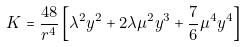Convert formula to latex. <formula><loc_0><loc_0><loc_500><loc_500>K = \frac { 4 8 } { r ^ { 4 } } \left [ \lambda ^ { 2 } y ^ { 2 } + 2 \lambda \mu ^ { 2 } y ^ { 3 } + \frac { 7 } { 6 } \mu ^ { 4 } y ^ { 4 } \right ]</formula> 